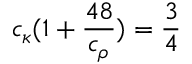Convert formula to latex. <formula><loc_0><loc_0><loc_500><loc_500>c _ { \kappa } { ( 1 + \frac { 4 8 } { c _ { \rho } } ) } = \frac { 3 } { 4 }</formula> 